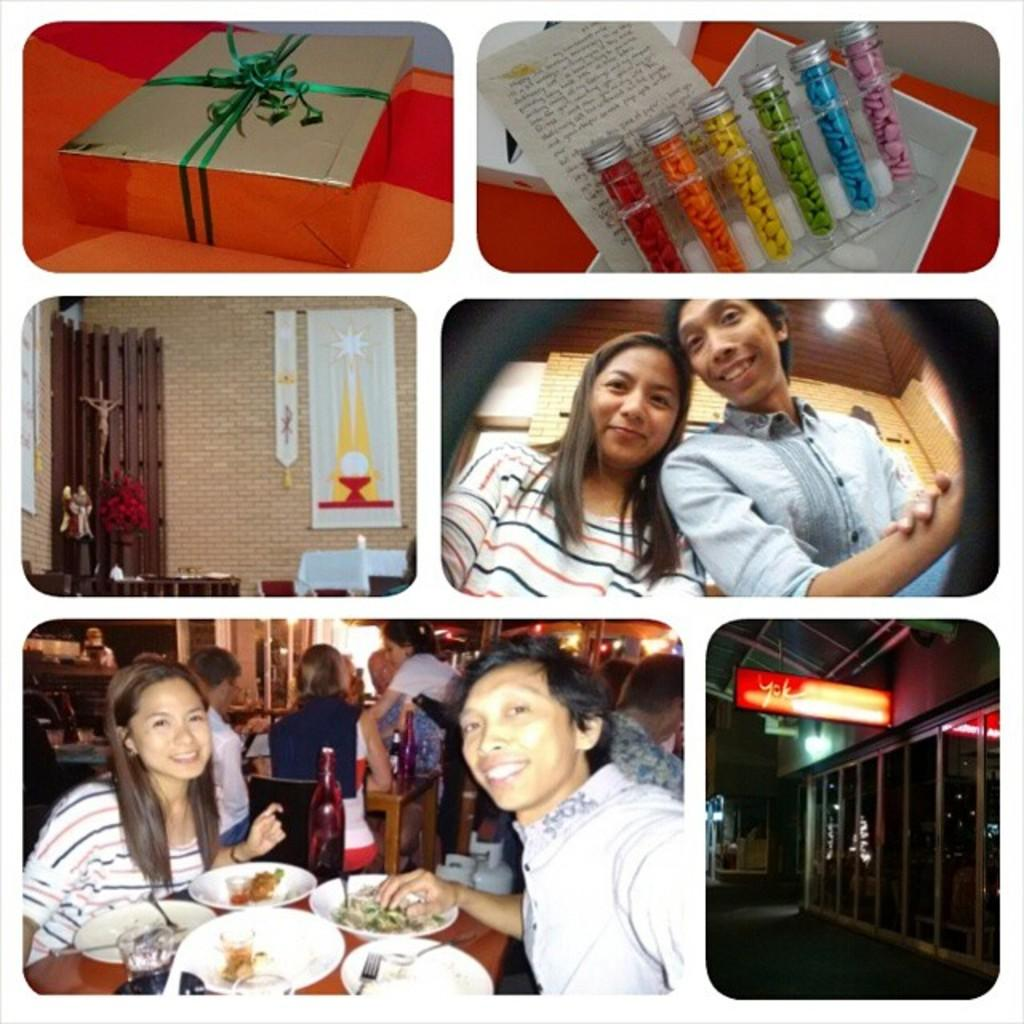What object can be seen in the image that is typically used for storage or packaging? There is a box in the image. What type of structure is visible in the image? There is a wall in the image. What type of item is present in the image that is typically used for writing or reading? There is a paper in the image. How many people are sitting in the image? There are two people sitting in the image. What type of furniture is visible in the image that is typically used for placing objects on? There is a table in the image. What type of beverage container is present on the table in the image? There is a bottle on the table. What type of dishware is present on the table in the image? There are plates and a bowl on the table. What type of pleasure can be seen being derived from the pot in the image? There is no pot present in the image, and therefore no pleasure can be derived from it. How does the person in the image blow the air out of the bottle? There is no indication in the image that anyone is blowing air out of the bottle. 